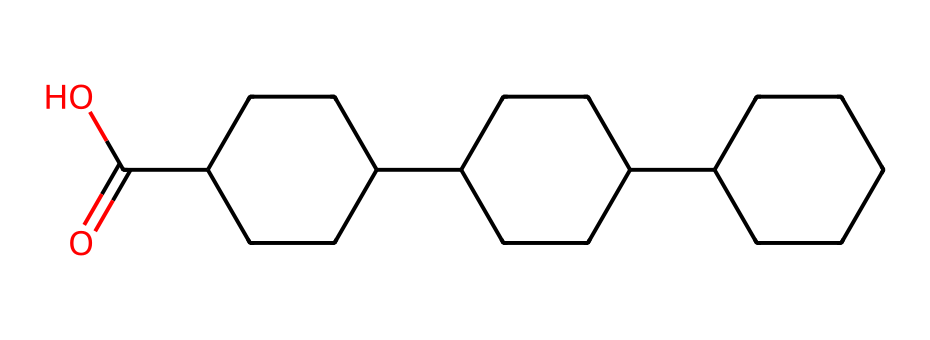What is the total number of carbon atoms in this structure? By examining the SMILES representation, I can count the carbon atoms explicitly represented. In the cycloalkane components, each "C" denotes a carbon. Counting gives me a total of 18 carbon atoms.
Answer: 18 How many rings are present in this compound? The structure includes multiple "C" sections arranged in a cyclical manner. Each distinct cycle formed indicates a ring. There are three distinct cycloalkane rings observed.
Answer: 3 What functional group is present in this compound? The presence of "C(=O)O" in the SMILES indicates a carboxylic acid functional group. The "=O" indicates a carbon double-bonded to oxygen and "O" indicates a hydroxyl (–OH) part, characteristic of carboxylic acids.
Answer: carboxylic acid What is the degree of unsaturation in this compound? The degree of unsaturation (DU) can be calculated using the formula: DU = (2C + 2 + N - H - X)/2. In this case, with 18 carbons and accounting for the hydrogen and functional groups, I find the DU to be 3, indicating the presence of 3 cycles or double bonds.
Answer: 3 Which type of cycloalkane does this compound represent? Analyzing the structure reveals that it comprises saturated carbon rings without any double bonds between carbons, indicating it is a type of cycloalkane. Being fully saturated, it is categorized as a bicyclic cycloalkane.
Answer: bicyclic cycloalkane What is the significance of the carboxylic acid group in graffiti-resistant coatings? The carboxylic acid functional group can enhance the adhesion properties of coatings. Its ability to form hydrogen bonds with surfaces improves the resistance against graffiti, making it more effective.
Answer: adhesion properties 